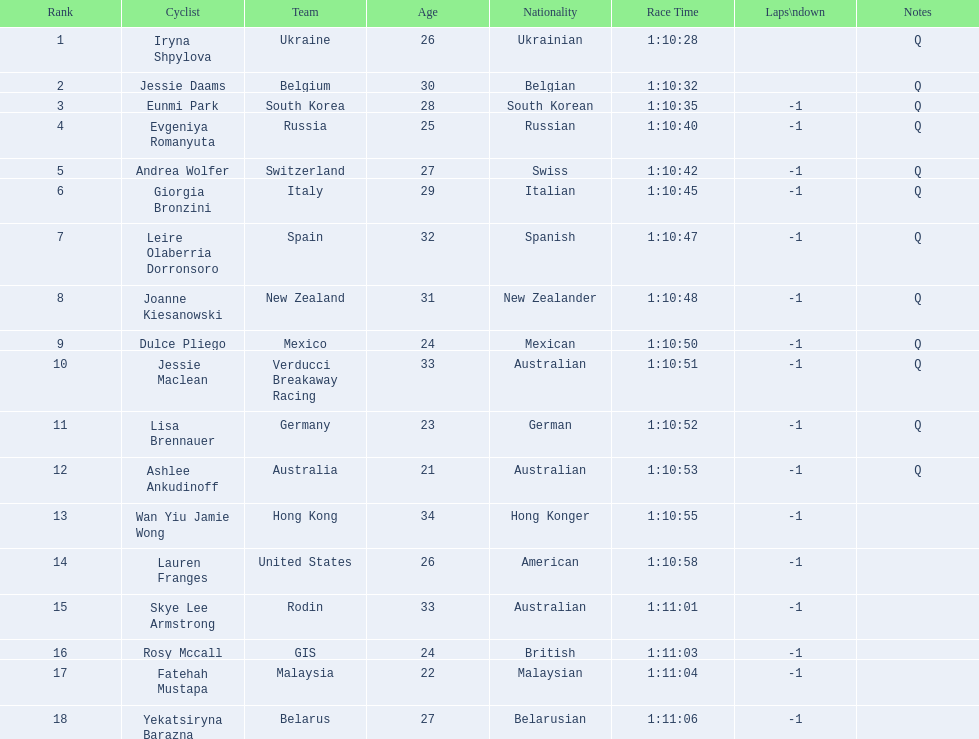Who are all of the cyclists in this race? Iryna Shpylova, Jessie Daams, Eunmi Park, Evgeniya Romanyuta, Andrea Wolfer, Giorgia Bronzini, Leire Olaberria Dorronsoro, Joanne Kiesanowski, Dulce Pliego, Jessie Maclean, Lisa Brennauer, Ashlee Ankudinoff, Wan Yiu Jamie Wong, Lauren Franges, Skye Lee Armstrong, Rosy Mccall, Fatehah Mustapa, Yekatsiryna Barazna. Of these, which one has the lowest numbered rank? Iryna Shpylova. 